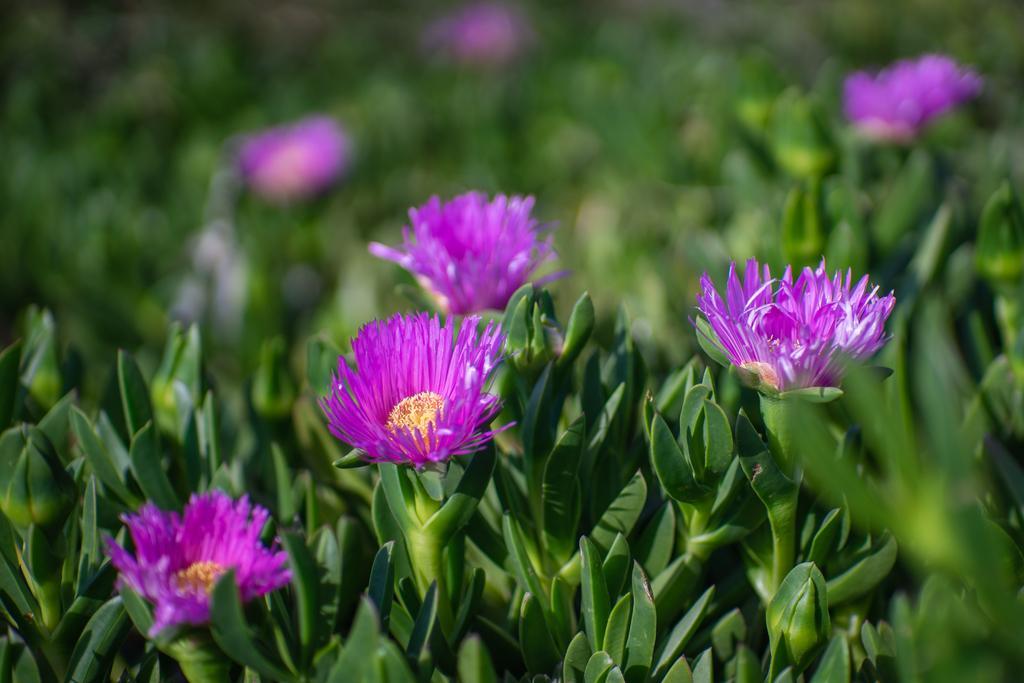Can you describe this image briefly? In this image we can see a group of plants with some flowers to them. 